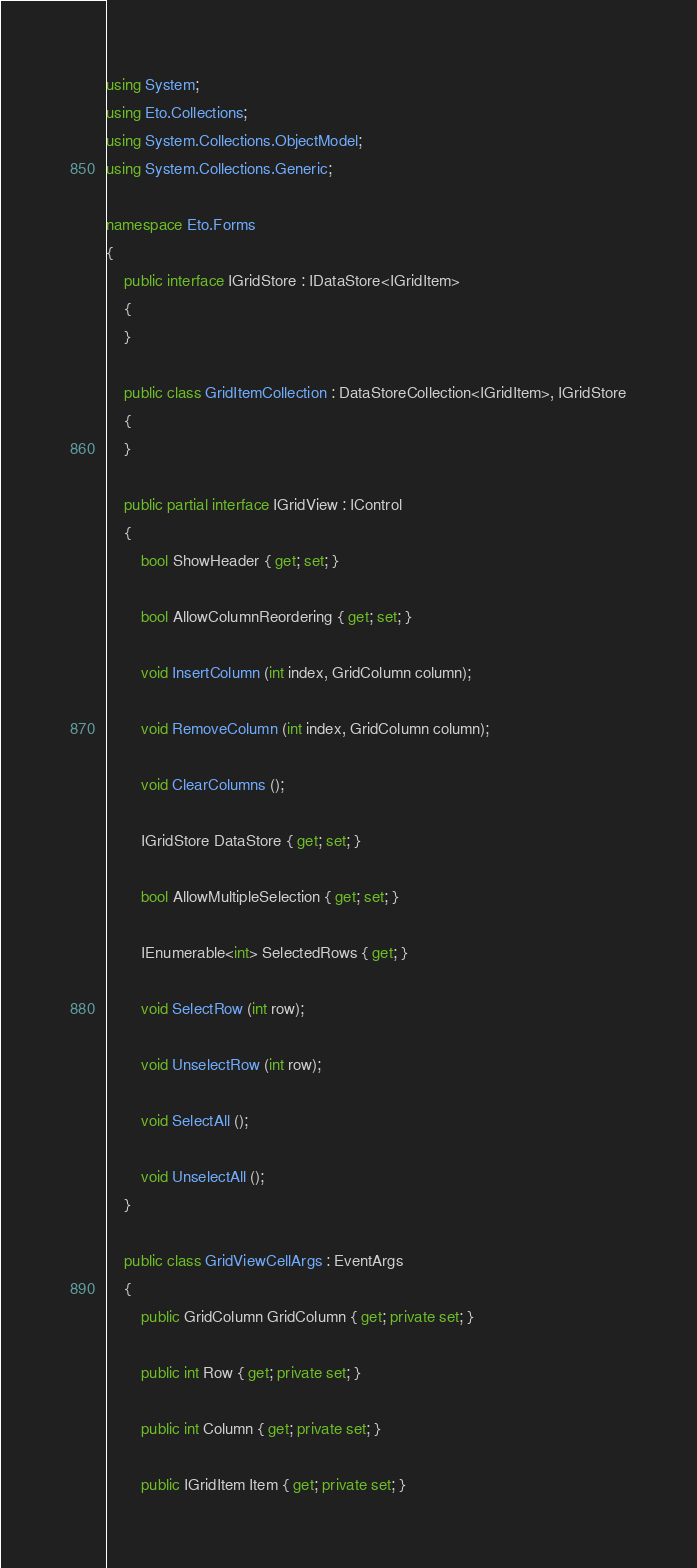Convert code to text. <code><loc_0><loc_0><loc_500><loc_500><_C#_>using System;
using Eto.Collections;
using System.Collections.ObjectModel;
using System.Collections.Generic;

namespace Eto.Forms
{
	public interface IGridStore : IDataStore<IGridItem>
	{
	}

	public class GridItemCollection : DataStoreCollection<IGridItem>, IGridStore
	{
	}

	public partial interface IGridView : IControl
	{
		bool ShowHeader { get; set; }

		bool AllowColumnReordering { get; set; }

		void InsertColumn (int index, GridColumn column);

		void RemoveColumn (int index, GridColumn column);

		void ClearColumns ();

		IGridStore DataStore { get; set; }

		bool AllowMultipleSelection { get; set; }

		IEnumerable<int> SelectedRows { get; }

		void SelectRow (int row);

		void UnselectRow (int row);

		void SelectAll ();

		void UnselectAll ();
	}

	public class GridViewCellArgs : EventArgs
	{
		public GridColumn GridColumn { get; private set; }

		public int Row { get; private set; }

		public int Column { get; private set; }

		public IGridItem Item { get; private set; }
</code> 